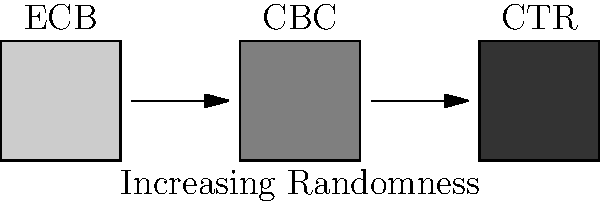Based on the visual representation of encrypted data using different symmetric encryption modes (ECB, CBC, CTR), which mode provides the highest level of security against pattern analysis attacks, and why? To answer this question, we need to analyze the visual representations of each encryption mode:

1. ECB (Electronic Codebook):
   - Represented by the lightest gray block
   - This indicates that patterns in the plaintext are preserved in the ciphertext
   - Vulnerable to pattern analysis attacks

2. CBC (Cipher Block Chaining):
   - Represented by the medium gray block
   - Shows improved randomness compared to ECB
   - Each block depends on the previous block, increasing diffusion

3. CTR (Counter):
   - Represented by the darkest gray block
   - Exhibits the highest level of randomness
   - Each block is encrypted independently with a unique counter value

The increasing darkness from ECB to CBC to CTR represents increasing randomness in the ciphertext. Higher randomness makes it more difficult for an attacker to discern patterns in the encrypted data.

CTR mode provides the highest level of security against pattern analysis attacks because:
1. It generates a unique keystream for each block, ensuring high randomness
2. The encryption of each block is independent, preventing error propagation
3. It effectively transforms the block cipher into a stream cipher, making it suitable for parallel processing and random access

Therefore, CTR mode offers the best protection against pattern analysis attacks among the three modes presented.
Answer: CTR (Counter) mode 